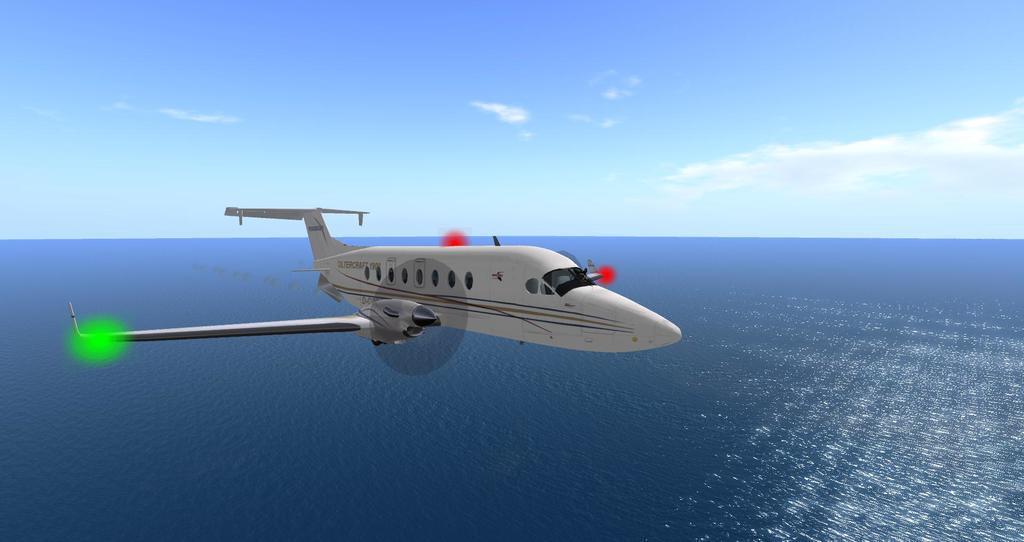Can you describe this image briefly? This image is taken outdoors. At the top of the image there is a sky with clouds. At the bottom of the image there is a sea. In the middle of the image an airplane is flying in the sky. 